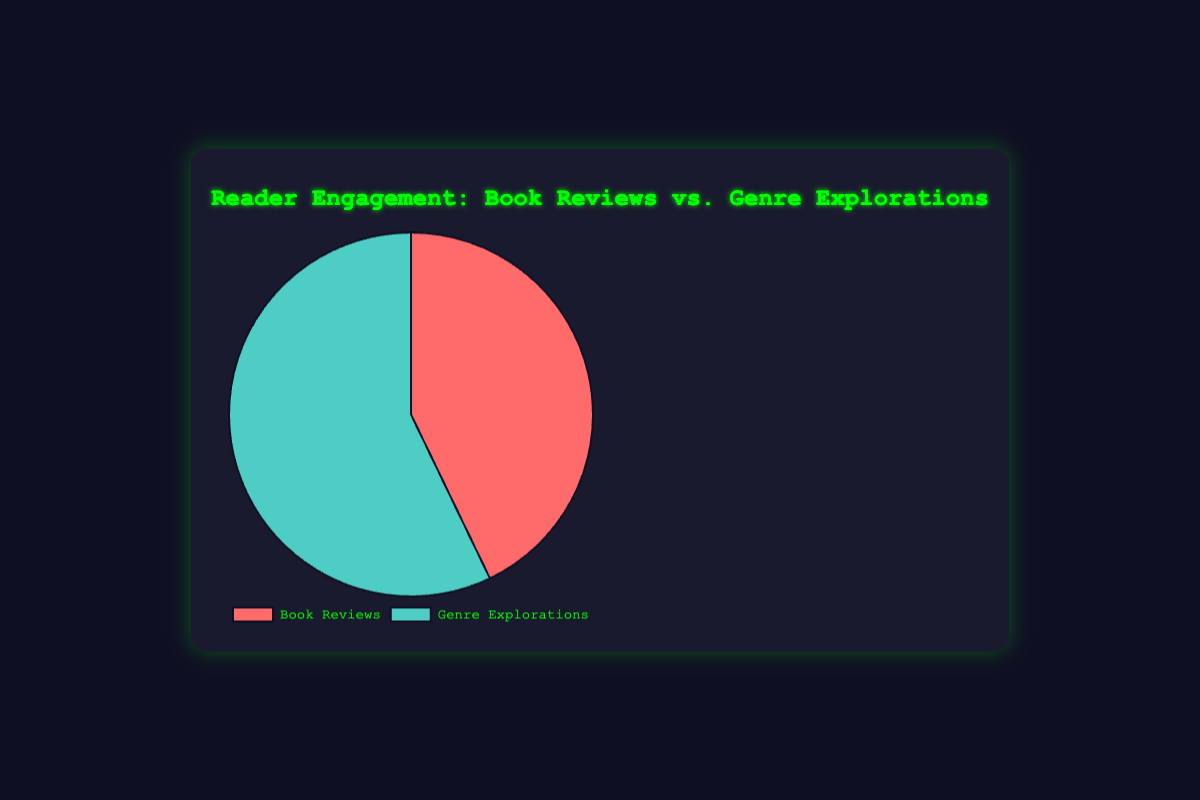What's the total engagement for both categories combined? Sum up the engagement of Book Reviews (135) and Genre Explorations (180): 135 + 180 = 315
Answer: 315 Which category has higher reader engagement? Compare the engagement: Book Reviews (135) vs. Genre Explorations (180). Genre Explorations have higher engagement.
Answer: Genre Explorations What is the difference in engagement between Book Reviews and Genre Explorations? Subtract the engagement of Book Reviews (135) from Genre Explorations (180): 180 - 135 = 45
Answer: 45 What percentage of the total engagement does Genre Explorations account for? Total engagement is 315. Genre Explorations have 180 engagements. Calculate the percentage: (180 / 315) * 100 ≈ 57.14%
Answer: 57.14% What fraction of the total engagement does Book Reviews represent? Total engagement is 315. Book Reviews have 135 engagements. Calculate the fraction: 135 / 315 = 3/7
Answer: 3/7 Which section in the pie chart is labeled with a light blue color? The data for Genre Explorations is represented in light blue color in the pie chart.
Answer: Genre Explorations How many more engagements does the Genre Explorations section have compared to the lowest rated book review? The lowest-rated book review is "Neuromancer Review" with 40 engagements. Genre Explorations have 180 engagements. The difference is 180 - 40 = 140
Answer: 140 What is the mean engagement per article in the Book Reviews category? Book Reviews have three articles: 45 + 50 + 40. The total is 135. Mean engagement is 135 / 3 ≈ 45
Answer: 45 